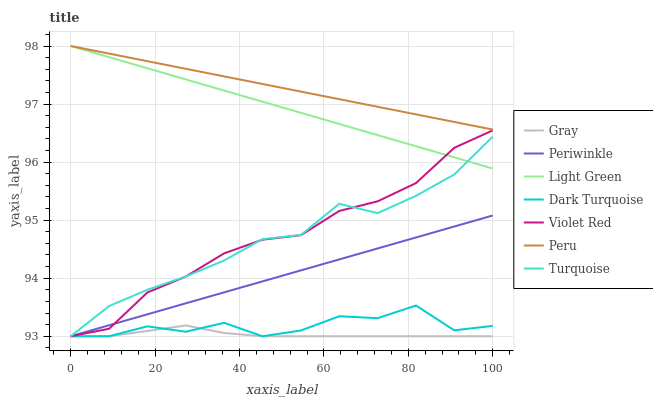Does Violet Red have the minimum area under the curve?
Answer yes or no. No. Does Violet Red have the maximum area under the curve?
Answer yes or no. No. Is Violet Red the smoothest?
Answer yes or no. No. Is Violet Red the roughest?
Answer yes or no. No. Does Light Green have the lowest value?
Answer yes or no. No. Does Violet Red have the highest value?
Answer yes or no. No. Is Dark Turquoise less than Light Green?
Answer yes or no. Yes. Is Peru greater than Periwinkle?
Answer yes or no. Yes. Does Dark Turquoise intersect Light Green?
Answer yes or no. No. 